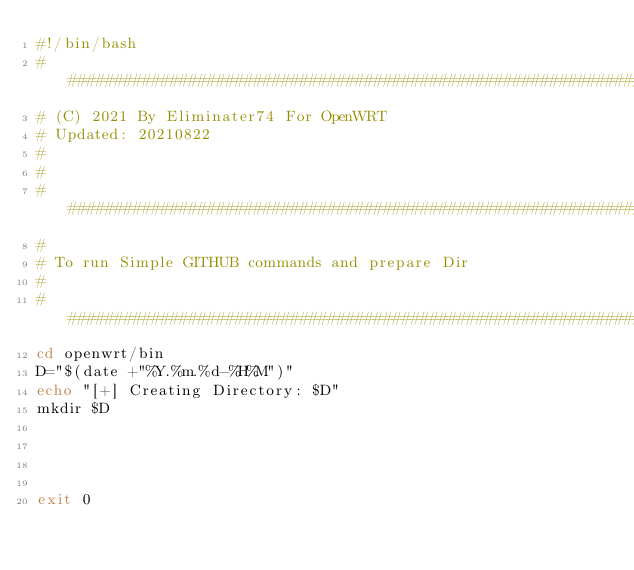<code> <loc_0><loc_0><loc_500><loc_500><_Bash_>#!/bin/bash
#################################################################
# (C) 2021 By Eliminater74 For OpenWRT
# Updated: 20210822
#
#
#################################################################
#
# To run Simple GITHUB commands and prepare Dir
#
#################################################################
cd openwrt/bin
D="$(date +"%Y.%m.%d-%H%M")"
echo "[+] Creating Directory: $D"
mkdir $D




exit 0
</code> 